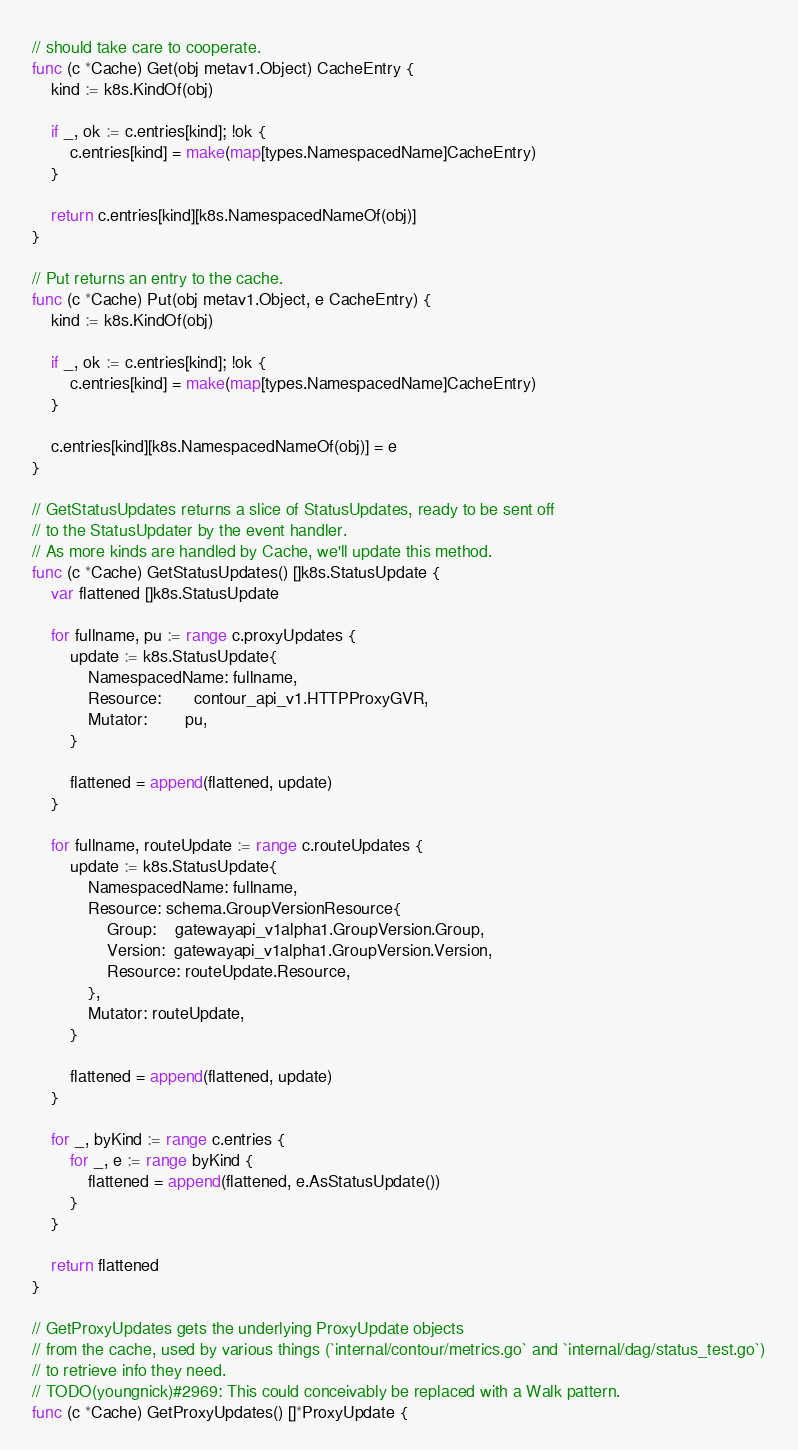Convert code to text. <code><loc_0><loc_0><loc_500><loc_500><_Go_>// should take care to cooperate.
func (c *Cache) Get(obj metav1.Object) CacheEntry {
	kind := k8s.KindOf(obj)

	if _, ok := c.entries[kind]; !ok {
		c.entries[kind] = make(map[types.NamespacedName]CacheEntry)
	}

	return c.entries[kind][k8s.NamespacedNameOf(obj)]
}

// Put returns an entry to the cache.
func (c *Cache) Put(obj metav1.Object, e CacheEntry) {
	kind := k8s.KindOf(obj)

	if _, ok := c.entries[kind]; !ok {
		c.entries[kind] = make(map[types.NamespacedName]CacheEntry)
	}

	c.entries[kind][k8s.NamespacedNameOf(obj)] = e
}

// GetStatusUpdates returns a slice of StatusUpdates, ready to be sent off
// to the StatusUpdater by the event handler.
// As more kinds are handled by Cache, we'll update this method.
func (c *Cache) GetStatusUpdates() []k8s.StatusUpdate {
	var flattened []k8s.StatusUpdate

	for fullname, pu := range c.proxyUpdates {
		update := k8s.StatusUpdate{
			NamespacedName: fullname,
			Resource:       contour_api_v1.HTTPProxyGVR,
			Mutator:        pu,
		}

		flattened = append(flattened, update)
	}

	for fullname, routeUpdate := range c.routeUpdates {
		update := k8s.StatusUpdate{
			NamespacedName: fullname,
			Resource: schema.GroupVersionResource{
				Group:    gatewayapi_v1alpha1.GroupVersion.Group,
				Version:  gatewayapi_v1alpha1.GroupVersion.Version,
				Resource: routeUpdate.Resource,
			},
			Mutator: routeUpdate,
		}

		flattened = append(flattened, update)
	}

	for _, byKind := range c.entries {
		for _, e := range byKind {
			flattened = append(flattened, e.AsStatusUpdate())
		}
	}

	return flattened
}

// GetProxyUpdates gets the underlying ProxyUpdate objects
// from the cache, used by various things (`internal/contour/metrics.go` and `internal/dag/status_test.go`)
// to retrieve info they need.
// TODO(youngnick)#2969: This could conceivably be replaced with a Walk pattern.
func (c *Cache) GetProxyUpdates() []*ProxyUpdate {</code> 